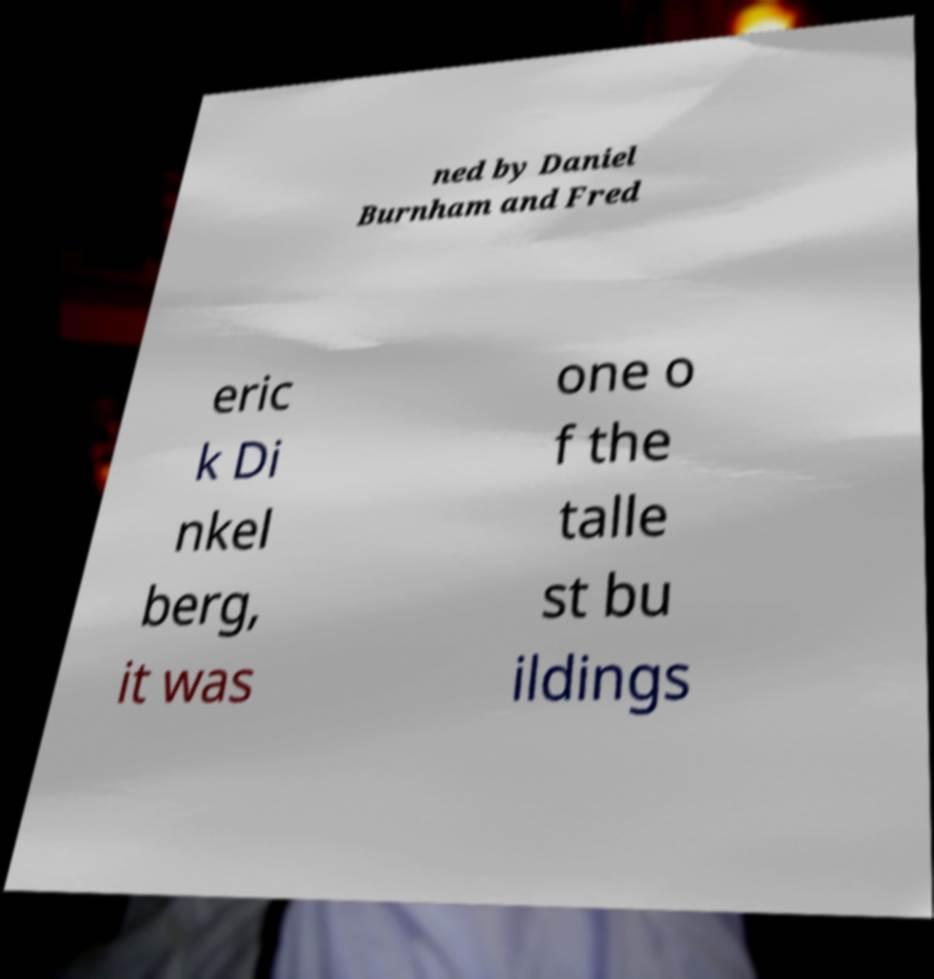Please read and relay the text visible in this image. What does it say? ned by Daniel Burnham and Fred eric k Di nkel berg, it was one o f the talle st bu ildings 